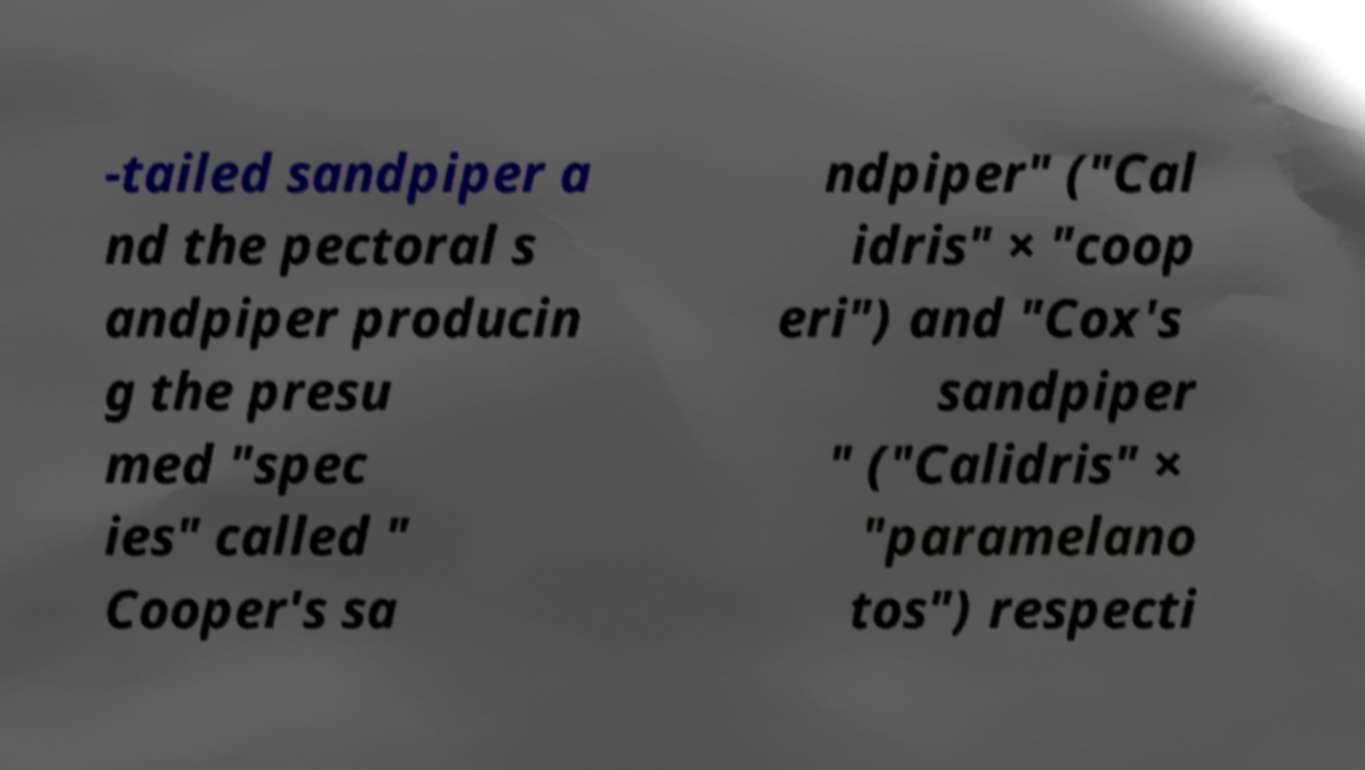What messages or text are displayed in this image? I need them in a readable, typed format. -tailed sandpiper a nd the pectoral s andpiper producin g the presu med "spec ies" called " Cooper's sa ndpiper" ("Cal idris" × "coop eri") and "Cox's sandpiper " ("Calidris" × "paramelano tos") respecti 